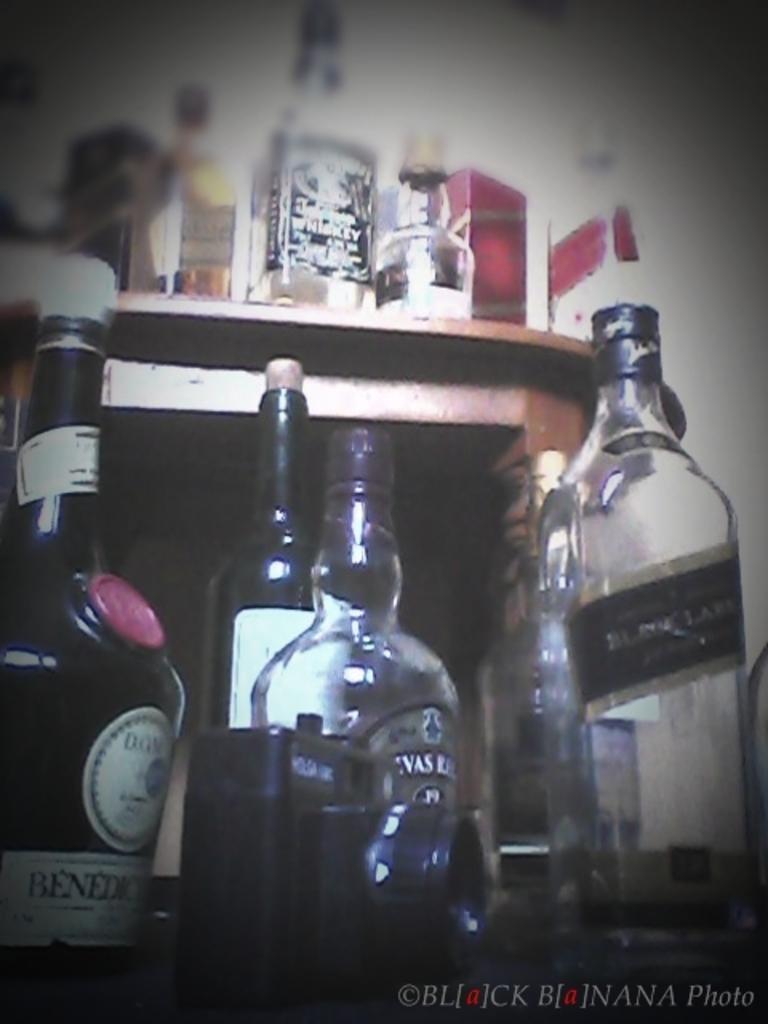Please provide a concise description of this image. In this image we can see a few wine bottles which are kept on the floor and this is a wooden table where a few wine bottles are kept on it. 